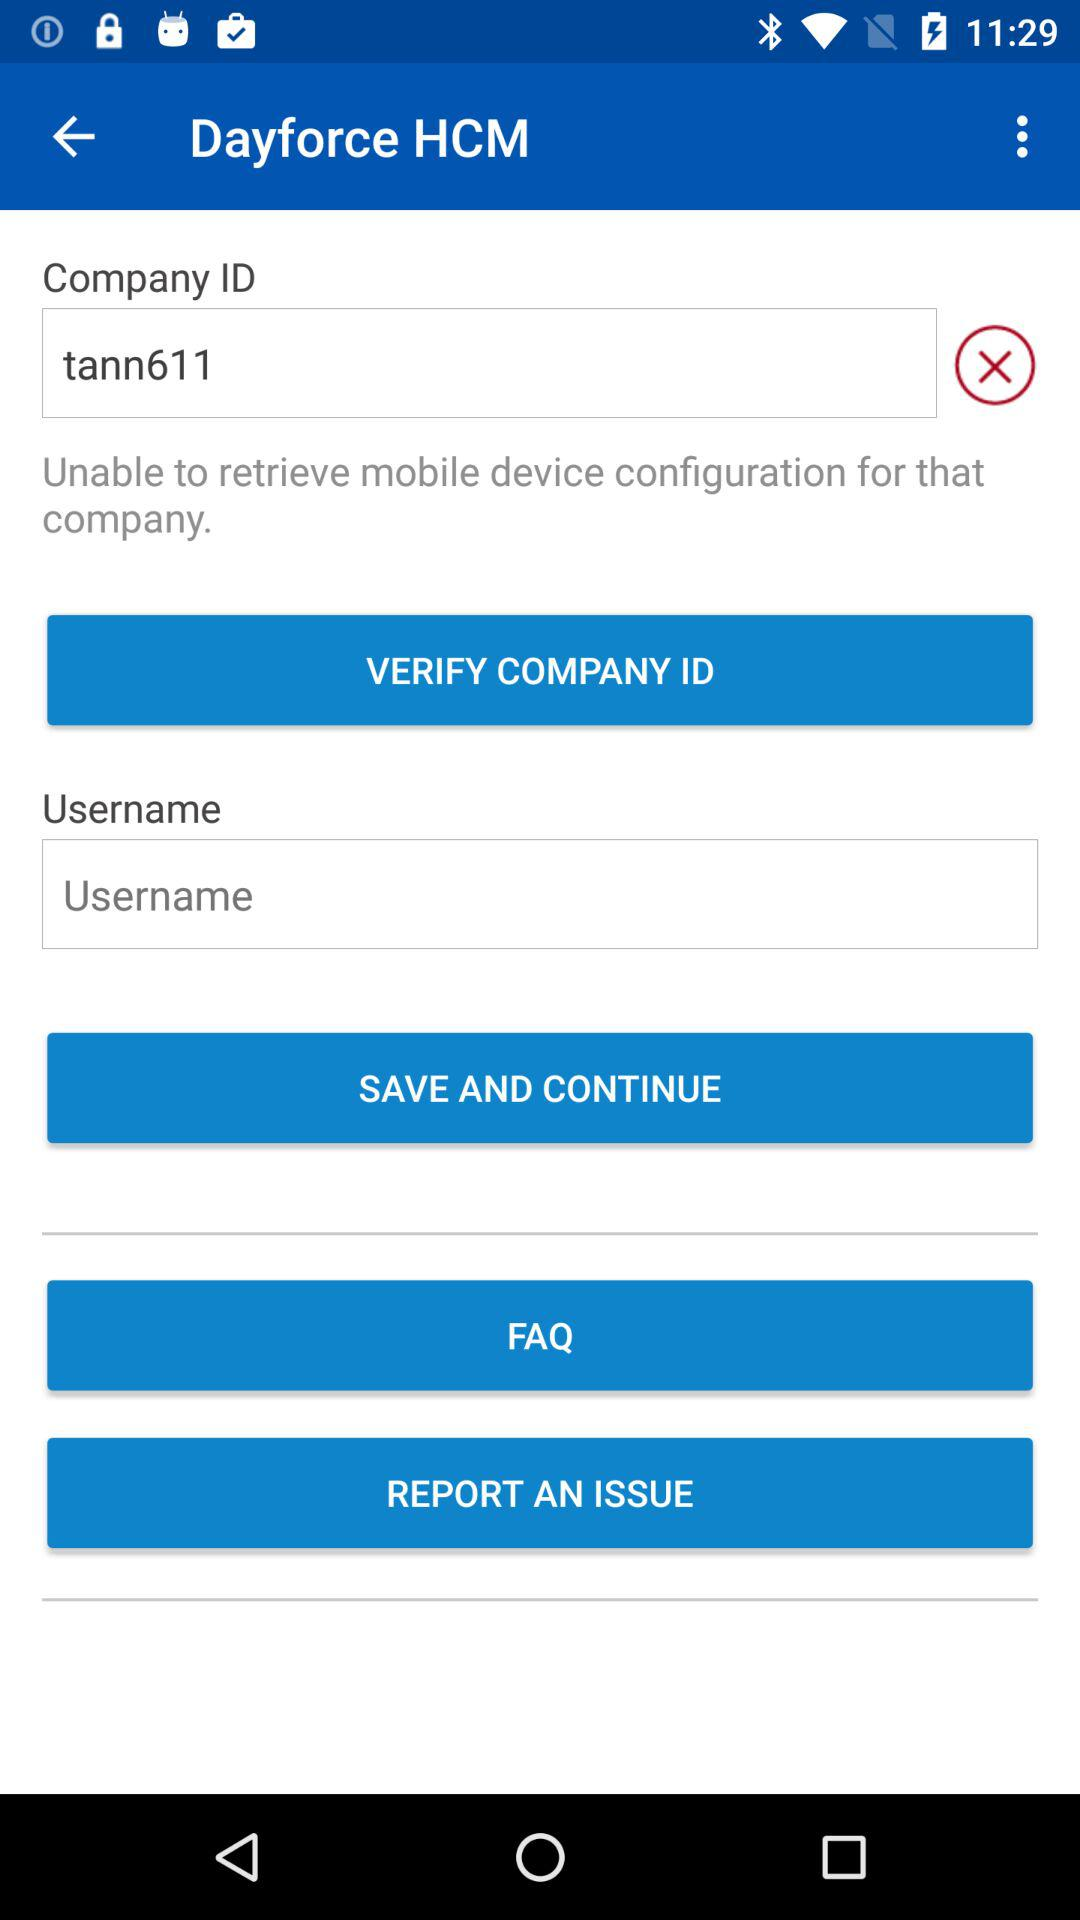What is the username?
When the provided information is insufficient, respond with <no answer>. <no answer> 